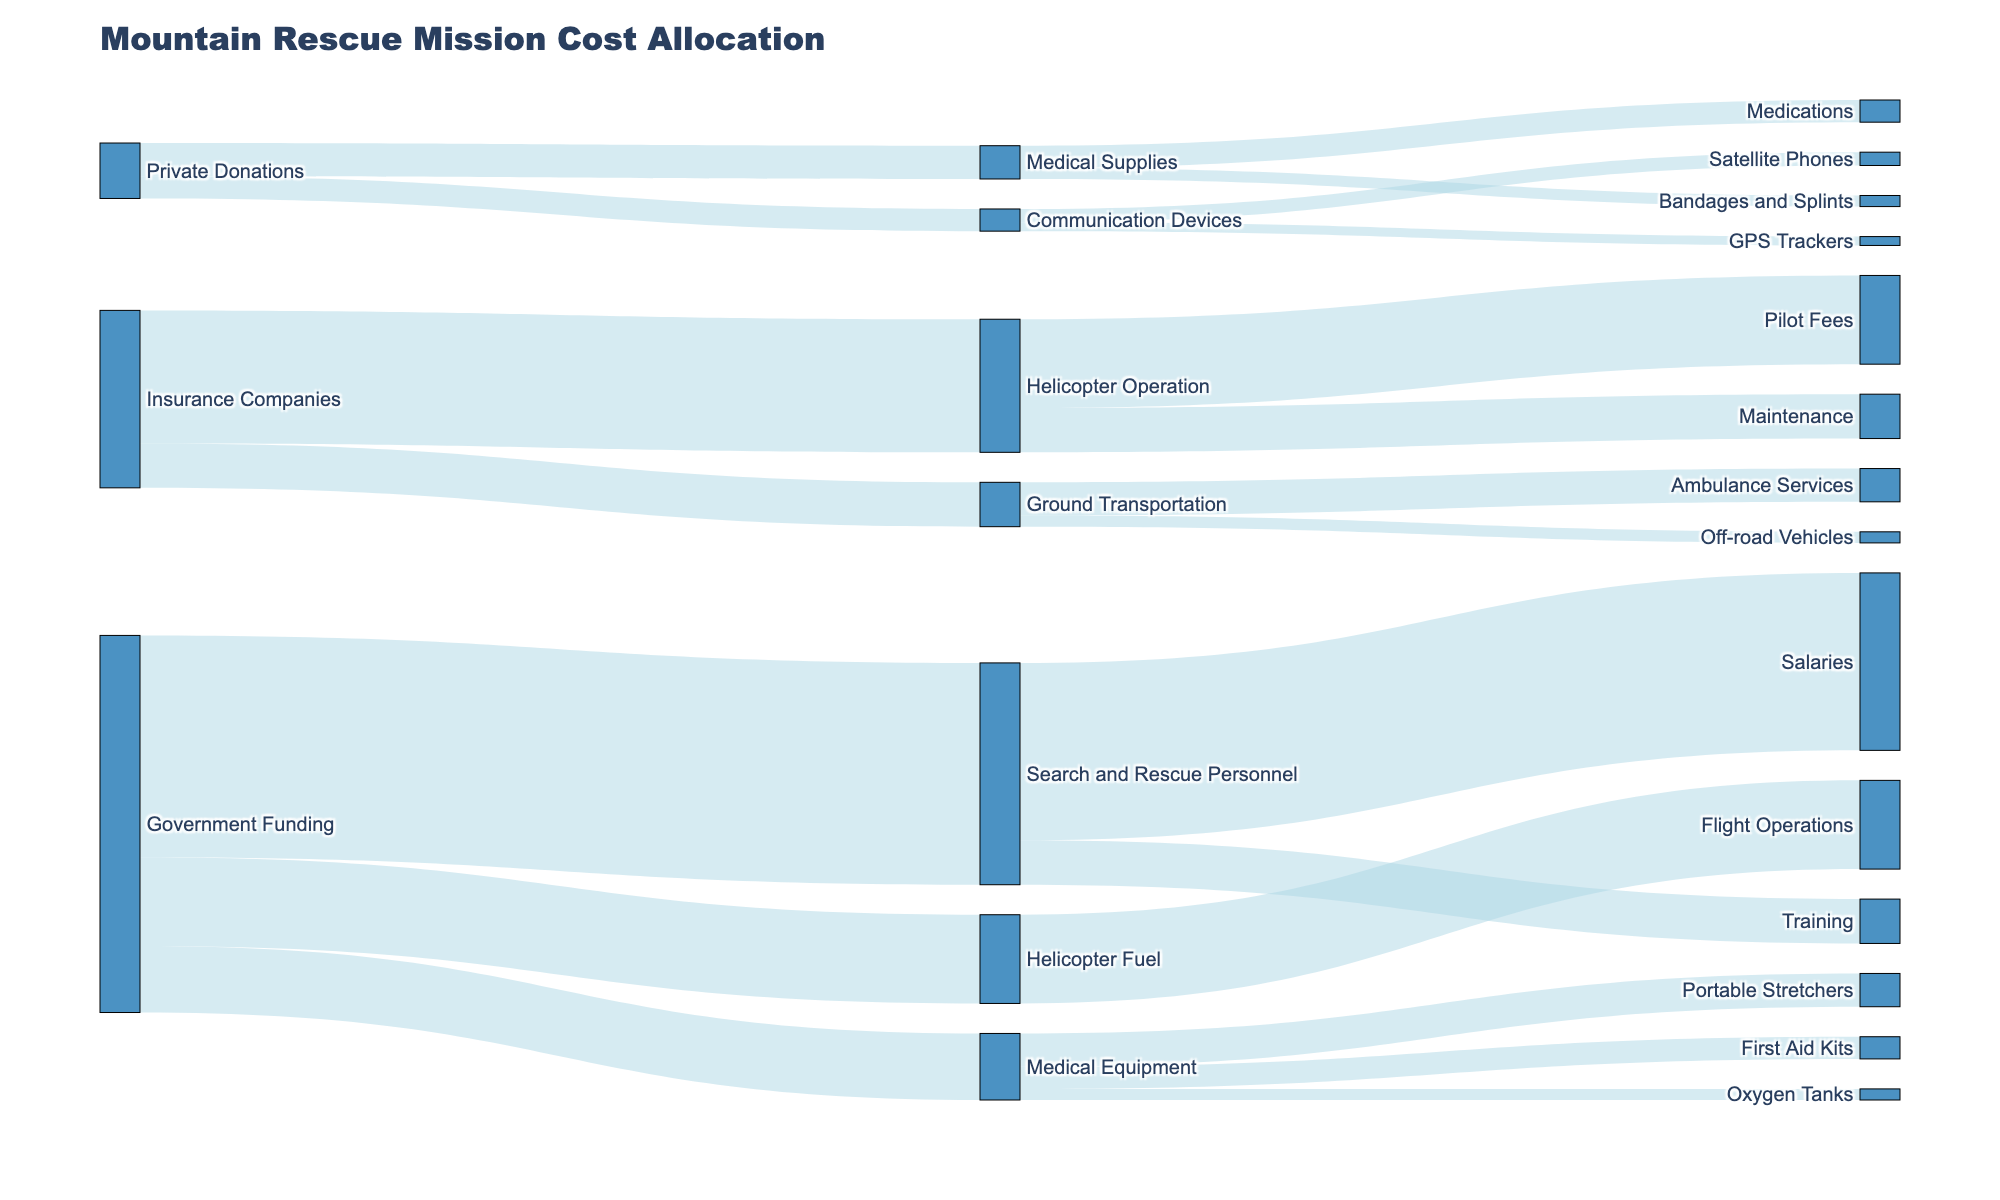What is the title of the figure? The title is typically found at the top of the figure. Here, it is "Mountain Rescue Mission Cost Allocation".
Answer: Mountain Rescue Mission Cost Allocation Which expense category receives the most funding from Government Funding? Observe the width of the links originating from "Government Funding". The widest link goes to "Search and Rescue Personnel", which implies it receives the most funding.
Answer: Search and Rescue Personnel Which funding source contributes to the Pilot Fees? Follow the path from "Pilot Fees" back to its connected node. "Pilot Fees" is funded by "Helicopter Operation", which in turn is funded by "Insurance Companies".
Answer: Insurance Companies How much total funding does Medical Equipment receive from Government Funding? Trace all paths from "Government Funding" to "Medical Equipment". There is only one link with a value of 150,000.
Answer: 150,000 Compare the funding for Flight Operations vs Ambulance Services. Which has a higher value and by how much? Flight Operations receives 200,000 and Ambulance Services gets 75,000. The difference is 200,000 - 75,000 = 125,000, so Flight Operations has a higher value by 125,000.
Answer: Flight Operations by 125,000 What is the total funding received by Medical Supplies from Private Donations? Only one link connects "Private Donations" to "Medical Supplies", valued at 75,000.
Answer: 75,000 How many different funding sources are shown? Count the unique nodes that act as funding sources. They are "Government Funding", "Private Donations", and "Insurance Companies", so there are three.
Answer: 3 What is the total funding allocated to Communication Devices from Private Donations and how is it distributed among the expense subcategories? First, see the total value from "Private Donations" to "Communication Devices," which is 50,000. Next, look at the distribution: 30,000 for Satellite Phones and 20,000 for GPS Trackers, summing to 50,000.
Answer: 50,000; Satellite Phones: 30,000, GPS Trackers: 20,000 